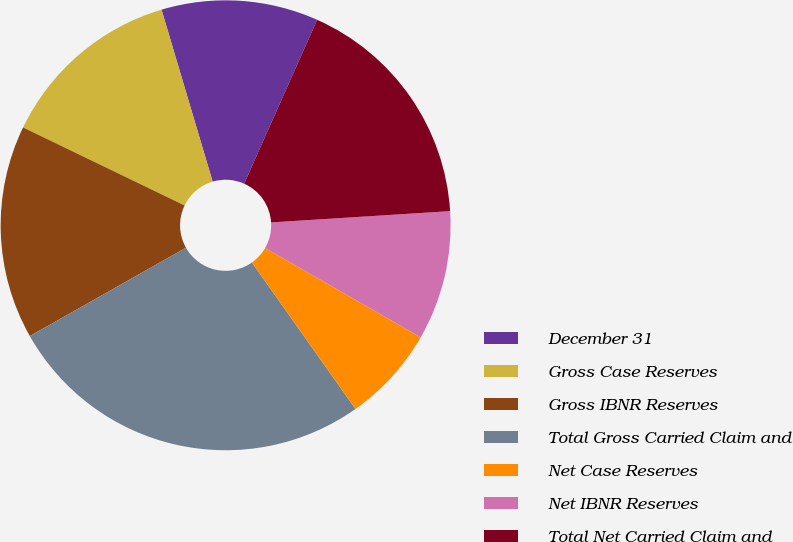Convert chart. <chart><loc_0><loc_0><loc_500><loc_500><pie_chart><fcel>December 31<fcel>Gross Case Reserves<fcel>Gross IBNR Reserves<fcel>Total Gross Carried Claim and<fcel>Net Case Reserves<fcel>Net IBNR Reserves<fcel>Total Net Carried Claim and<nl><fcel>11.27%<fcel>13.24%<fcel>15.36%<fcel>26.6%<fcel>6.91%<fcel>9.3%<fcel>17.33%<nl></chart> 